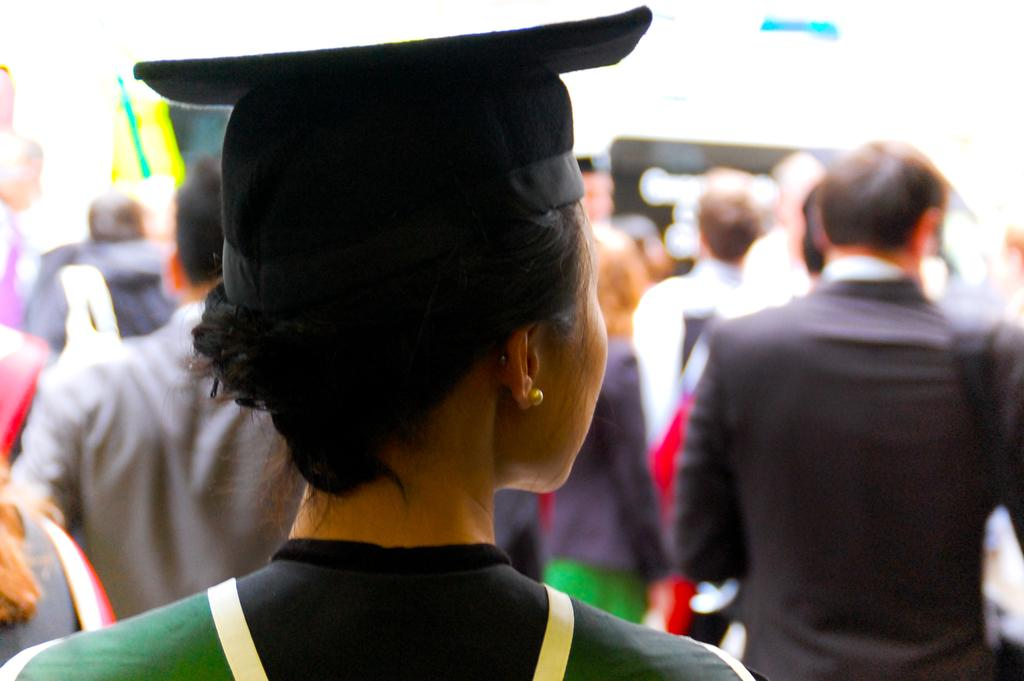Who is the main subject in the foreground of the image? There is a woman in the foreground of the image. What is the woman wearing on her head? The woman is wearing a hat. Can you describe the background of the image? There are many other people behind the woman in the image. What type of board can be seen being used by the woman in the image? There is no board present in the image; the woman is wearing a hat and standing among other people. 